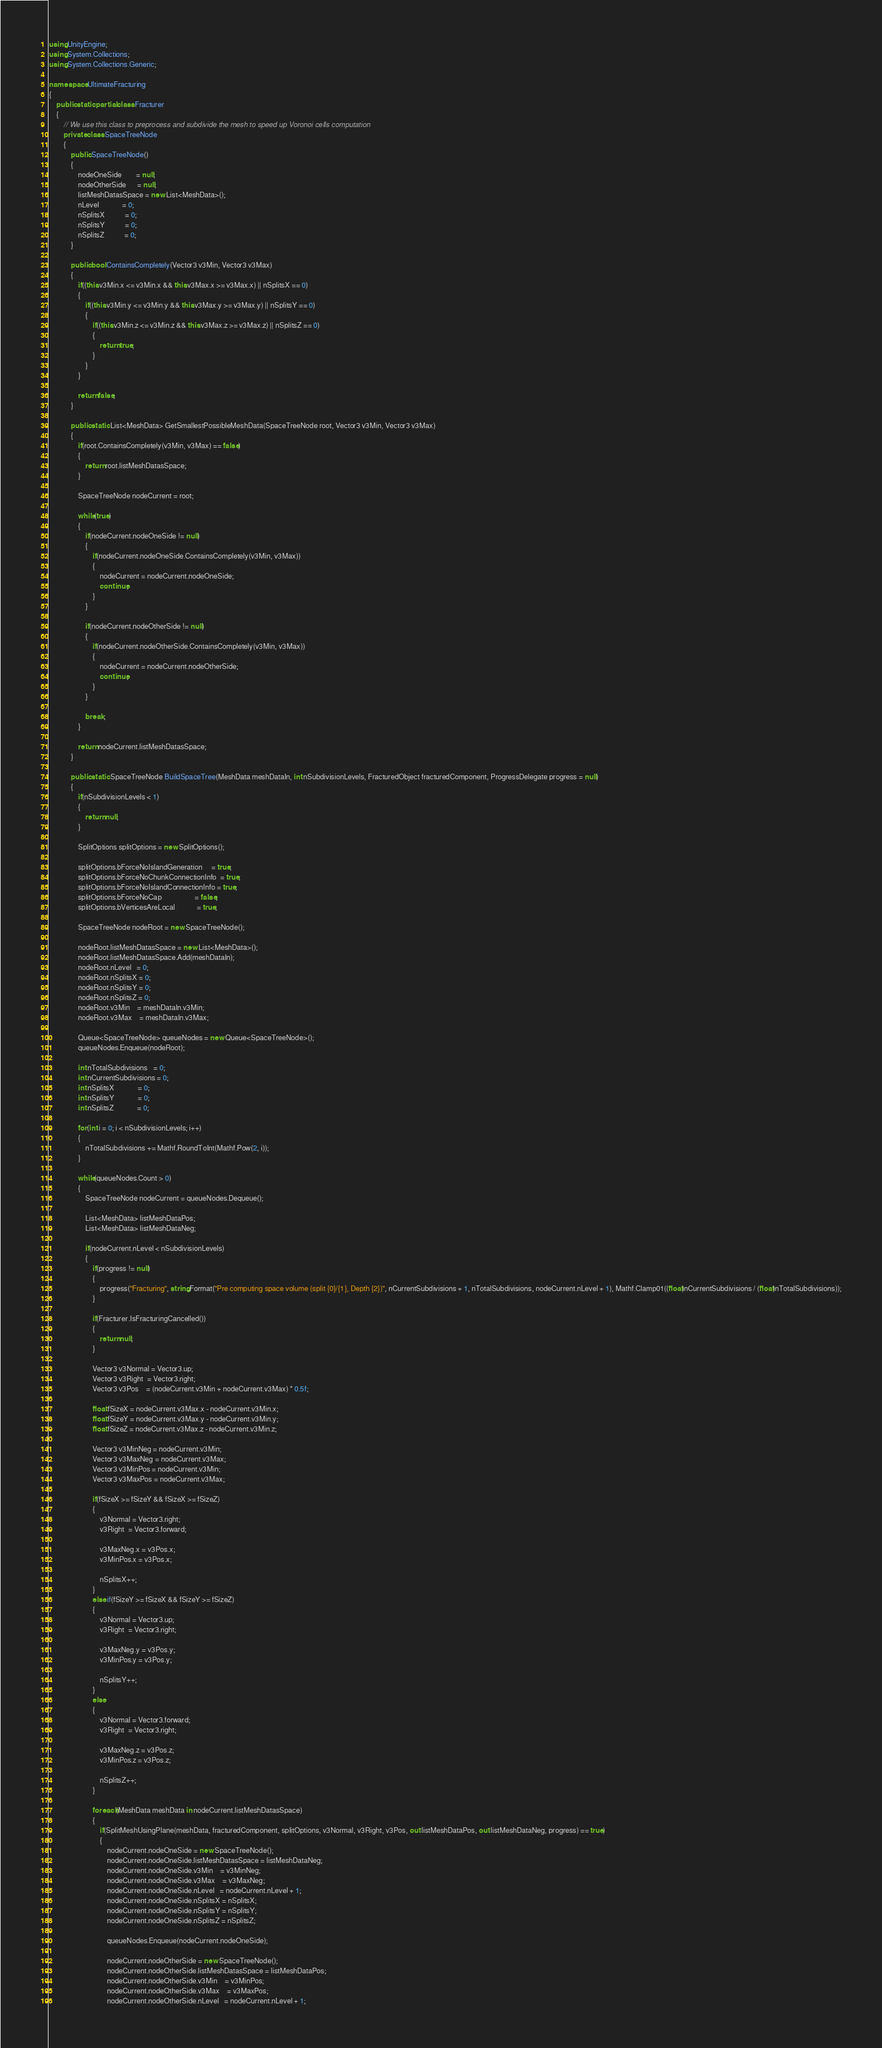Convert code to text. <code><loc_0><loc_0><loc_500><loc_500><_C#_>using UnityEngine;
using System.Collections;
using System.Collections.Generic;

namespace UltimateFracturing
{
    public static partial class Fracturer
    {
        // We use this class to preprocess and subdivide the mesh to speed up Voronoi cells computation
        private class SpaceTreeNode
        {
            public SpaceTreeNode()
            {
                nodeOneSide        = null;
                nodeOtherSide      = null;
                listMeshDatasSpace = new List<MeshData>();
                nLevel             = 0;
                nSplitsX           = 0;
                nSplitsY           = 0;
                nSplitsZ           = 0;
            }

            public bool ContainsCompletely(Vector3 v3Min, Vector3 v3Max)
            {
                if((this.v3Min.x <= v3Min.x && this.v3Max.x >= v3Max.x) || nSplitsX == 0)
                {
                    if((this.v3Min.y <= v3Min.y && this.v3Max.y >= v3Max.y) || nSplitsY == 0)
                    {
                        if((this.v3Min.z <= v3Min.z && this.v3Max.z >= v3Max.z) || nSplitsZ == 0)
                        {
                            return true;
                        }
                    }
                }

                return false;
            }

            public static List<MeshData> GetSmallestPossibleMeshData(SpaceTreeNode root, Vector3 v3Min, Vector3 v3Max)
            {
                if(root.ContainsCompletely(v3Min, v3Max) == false)
                {
                    return root.listMeshDatasSpace;
                }

                SpaceTreeNode nodeCurrent = root;

                while(true)
                {
                    if(nodeCurrent.nodeOneSide != null)
                    {
                        if(nodeCurrent.nodeOneSide.ContainsCompletely(v3Min, v3Max))
                        {
                            nodeCurrent = nodeCurrent.nodeOneSide;
                            continue;
                        }
                    }

                    if(nodeCurrent.nodeOtherSide != null)
                    {
                        if(nodeCurrent.nodeOtherSide.ContainsCompletely(v3Min, v3Max))
                        {
                            nodeCurrent = nodeCurrent.nodeOtherSide;
                            continue;
                        }
                    }

                    break;
                }

                return nodeCurrent.listMeshDatasSpace;
            }

            public static SpaceTreeNode BuildSpaceTree(MeshData meshDataIn, int nSubdivisionLevels, FracturedObject fracturedComponent, ProgressDelegate progress = null)
            {
                if(nSubdivisionLevels < 1)
                {
                    return null;
                }

                SplitOptions splitOptions = new SplitOptions();

                splitOptions.bForceNoIslandGeneration     = true;
                splitOptions.bForceNoChunkConnectionInfo  = true;            
                splitOptions.bForceNoIslandConnectionInfo = true;
                splitOptions.bForceNoCap                  = false;
                splitOptions.bVerticesAreLocal            = true;

                SpaceTreeNode nodeRoot = new SpaceTreeNode();

                nodeRoot.listMeshDatasSpace = new List<MeshData>();
                nodeRoot.listMeshDatasSpace.Add(meshDataIn);
                nodeRoot.nLevel   = 0;
                nodeRoot.nSplitsX = 0;
                nodeRoot.nSplitsY = 0;
                nodeRoot.nSplitsZ = 0;
                nodeRoot.v3Min    = meshDataIn.v3Min;
                nodeRoot.v3Max    = meshDataIn.v3Max;

                Queue<SpaceTreeNode> queueNodes = new Queue<SpaceTreeNode>();
                queueNodes.Enqueue(nodeRoot);

                int nTotalSubdivisions   = 0;
                int nCurrentSubdivisions = 0;
                int nSplitsX             = 0;
                int nSplitsY             = 0;
                int nSplitsZ             = 0;
                
                for(int i = 0; i < nSubdivisionLevels; i++)
                {
                    nTotalSubdivisions += Mathf.RoundToInt(Mathf.Pow(2, i));
                }

                while(queueNodes.Count > 0)
                {
                    SpaceTreeNode nodeCurrent = queueNodes.Dequeue();

                    List<MeshData> listMeshDataPos;
                    List<MeshData> listMeshDataNeg;

                    if(nodeCurrent.nLevel < nSubdivisionLevels)
                    {
                        if(progress != null)
                        {
                            progress("Fracturing", string.Format("Pre computing space volume (split {0}/{1}, Depth {2})", nCurrentSubdivisions + 1, nTotalSubdivisions, nodeCurrent.nLevel + 1), Mathf.Clamp01((float)nCurrentSubdivisions / (float)nTotalSubdivisions));
                        }

                        if(Fracturer.IsFracturingCancelled())
                        {
                            return null;
                        }

                        Vector3 v3Normal = Vector3.up;
                        Vector3 v3Right  = Vector3.right;
                        Vector3 v3Pos    = (nodeCurrent.v3Min + nodeCurrent.v3Max) * 0.5f;

                        float fSizeX = nodeCurrent.v3Max.x - nodeCurrent.v3Min.x;
                        float fSizeY = nodeCurrent.v3Max.y - nodeCurrent.v3Min.y;
                        float fSizeZ = nodeCurrent.v3Max.z - nodeCurrent.v3Min.z;

                        Vector3 v3MinNeg = nodeCurrent.v3Min;
                        Vector3 v3MaxNeg = nodeCurrent.v3Max;
                        Vector3 v3MinPos = nodeCurrent.v3Min;
                        Vector3 v3MaxPos = nodeCurrent.v3Max;

                        if(fSizeX >= fSizeY && fSizeX >= fSizeZ)
                        {
                            v3Normal = Vector3.right;
                            v3Right  = Vector3.forward;

                            v3MaxNeg.x = v3Pos.x;
                            v3MinPos.x = v3Pos.x;

                            nSplitsX++;
                        }
                        else if(fSizeY >= fSizeX && fSizeY >= fSizeZ)
                        {
                            v3Normal = Vector3.up;
                            v3Right  = Vector3.right;

                            v3MaxNeg.y = v3Pos.y;
                            v3MinPos.y = v3Pos.y;

                            nSplitsY++;
                        }
                        else
                        {
                            v3Normal = Vector3.forward;
                            v3Right  = Vector3.right;

                            v3MaxNeg.z = v3Pos.z;
                            v3MinPos.z = v3Pos.z;

                            nSplitsZ++;
                        }

                        foreach(MeshData meshData in nodeCurrent.listMeshDatasSpace)
                        {
                            if(SplitMeshUsingPlane(meshData, fracturedComponent, splitOptions, v3Normal, v3Right, v3Pos, out listMeshDataPos, out listMeshDataNeg, progress) == true)
                            {
                                nodeCurrent.nodeOneSide = new SpaceTreeNode();
                                nodeCurrent.nodeOneSide.listMeshDatasSpace = listMeshDataNeg;
                                nodeCurrent.nodeOneSide.v3Min    = v3MinNeg;
                                nodeCurrent.nodeOneSide.v3Max    = v3MaxNeg;
                                nodeCurrent.nodeOneSide.nLevel   = nodeCurrent.nLevel + 1;
                                nodeCurrent.nodeOneSide.nSplitsX = nSplitsX;
                                nodeCurrent.nodeOneSide.nSplitsY = nSplitsY;
                                nodeCurrent.nodeOneSide.nSplitsZ = nSplitsZ;

                                queueNodes.Enqueue(nodeCurrent.nodeOneSide);

                                nodeCurrent.nodeOtherSide = new SpaceTreeNode();
                                nodeCurrent.nodeOtherSide.listMeshDatasSpace = listMeshDataPos;
                                nodeCurrent.nodeOtherSide.v3Min    = v3MinPos;
                                nodeCurrent.nodeOtherSide.v3Max    = v3MaxPos;
                                nodeCurrent.nodeOtherSide.nLevel   = nodeCurrent.nLevel + 1;</code> 